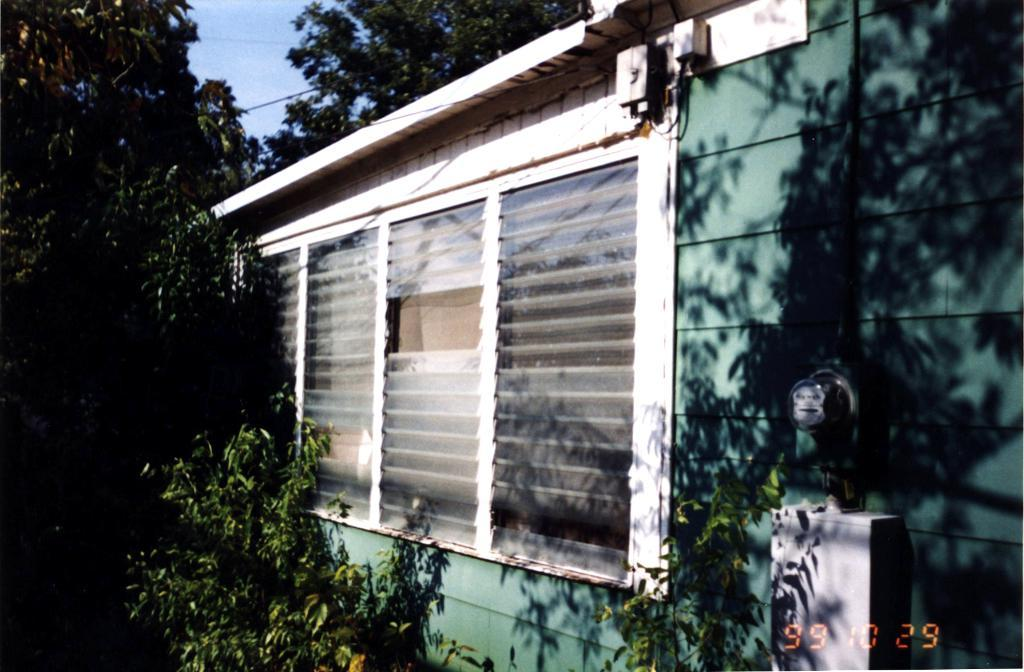What type of structure is in the image? There is a building in the image. What color is the building? The building is green. What type of windows are on the building? There are glass windows on the building. What can be seen in the background of the image? There are trees in the background of the image. What color are the trees? The trees are green. What color is the sky in the image? The sky is blue. What type of oatmeal is being served in the image? There is no oatmeal present in the image; it features a green building with glass windows, green trees in the background, and a blue sky. 